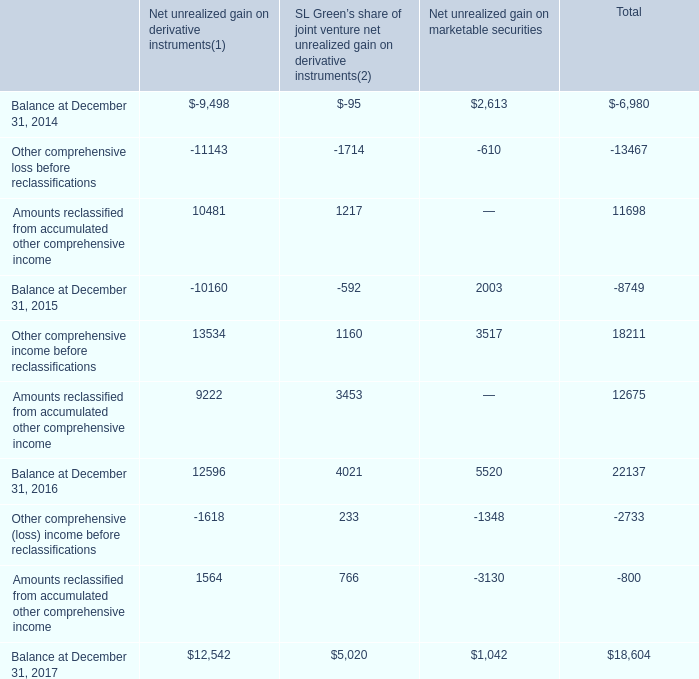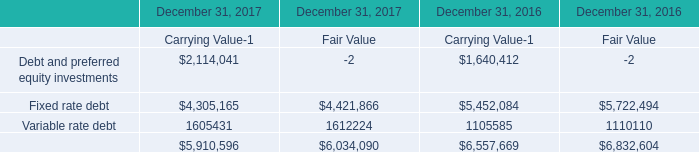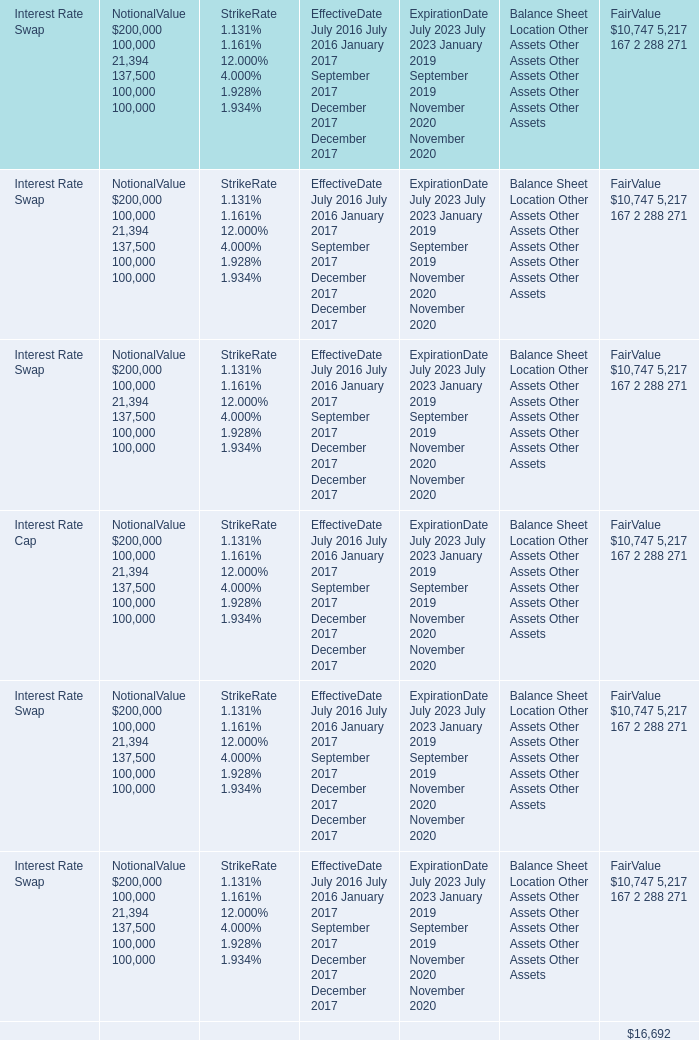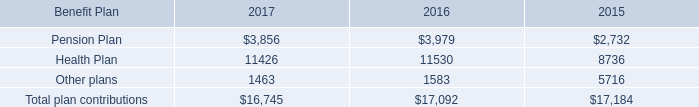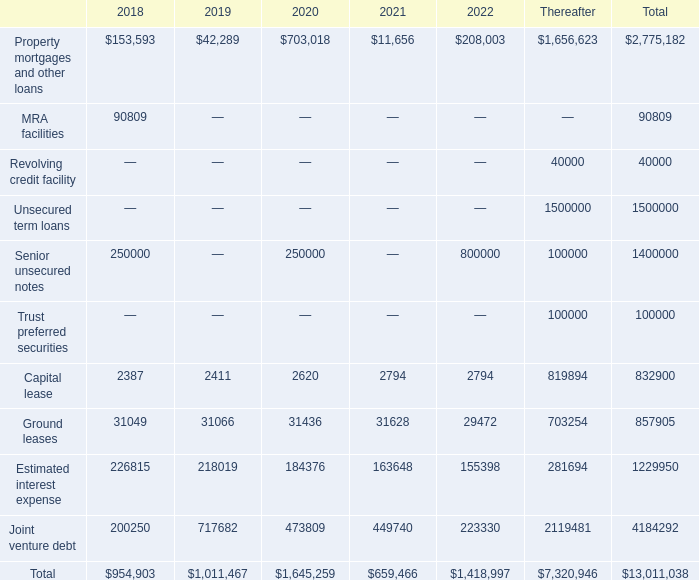What is the total amount of Other plans of 2015, and Ground leases of 2019 ? 
Computations: (5716.0 + 31066.0)
Answer: 36782.0. 